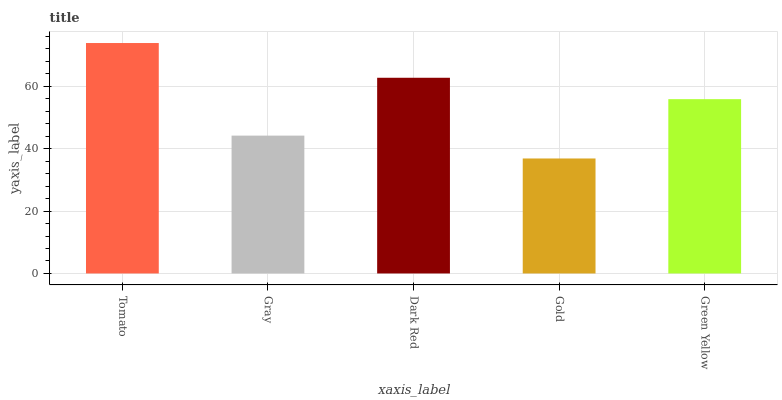Is Gold the minimum?
Answer yes or no. Yes. Is Tomato the maximum?
Answer yes or no. Yes. Is Gray the minimum?
Answer yes or no. No. Is Gray the maximum?
Answer yes or no. No. Is Tomato greater than Gray?
Answer yes or no. Yes. Is Gray less than Tomato?
Answer yes or no. Yes. Is Gray greater than Tomato?
Answer yes or no. No. Is Tomato less than Gray?
Answer yes or no. No. Is Green Yellow the high median?
Answer yes or no. Yes. Is Green Yellow the low median?
Answer yes or no. Yes. Is Dark Red the high median?
Answer yes or no. No. Is Gold the low median?
Answer yes or no. No. 